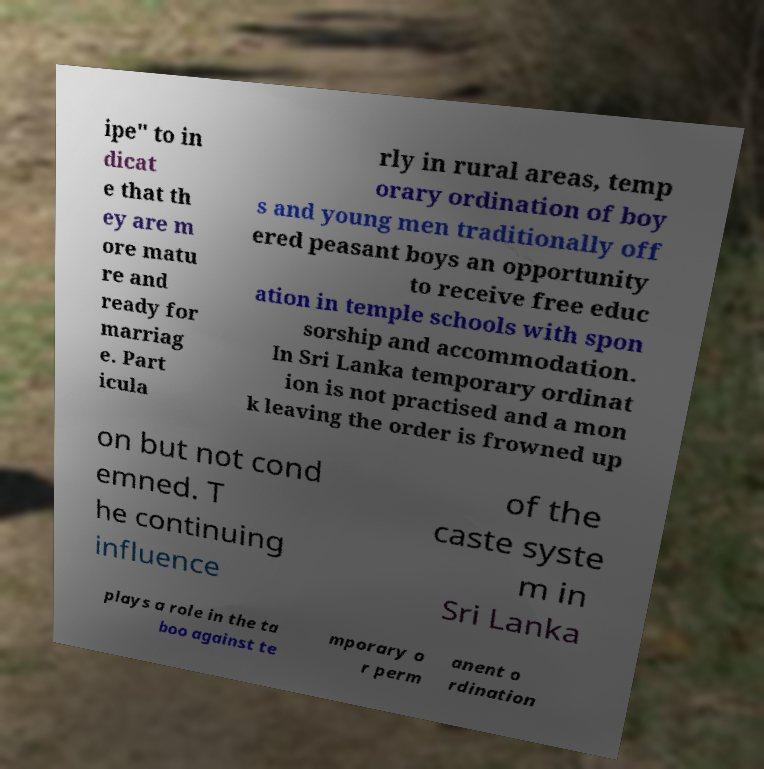Can you read and provide the text displayed in the image?This photo seems to have some interesting text. Can you extract and type it out for me? ipe" to in dicat e that th ey are m ore matu re and ready for marriag e. Part icula rly in rural areas, temp orary ordination of boy s and young men traditionally off ered peasant boys an opportunity to receive free educ ation in temple schools with spon sorship and accommodation. In Sri Lanka temporary ordinat ion is not practised and a mon k leaving the order is frowned up on but not cond emned. T he continuing influence of the caste syste m in Sri Lanka plays a role in the ta boo against te mporary o r perm anent o rdination 